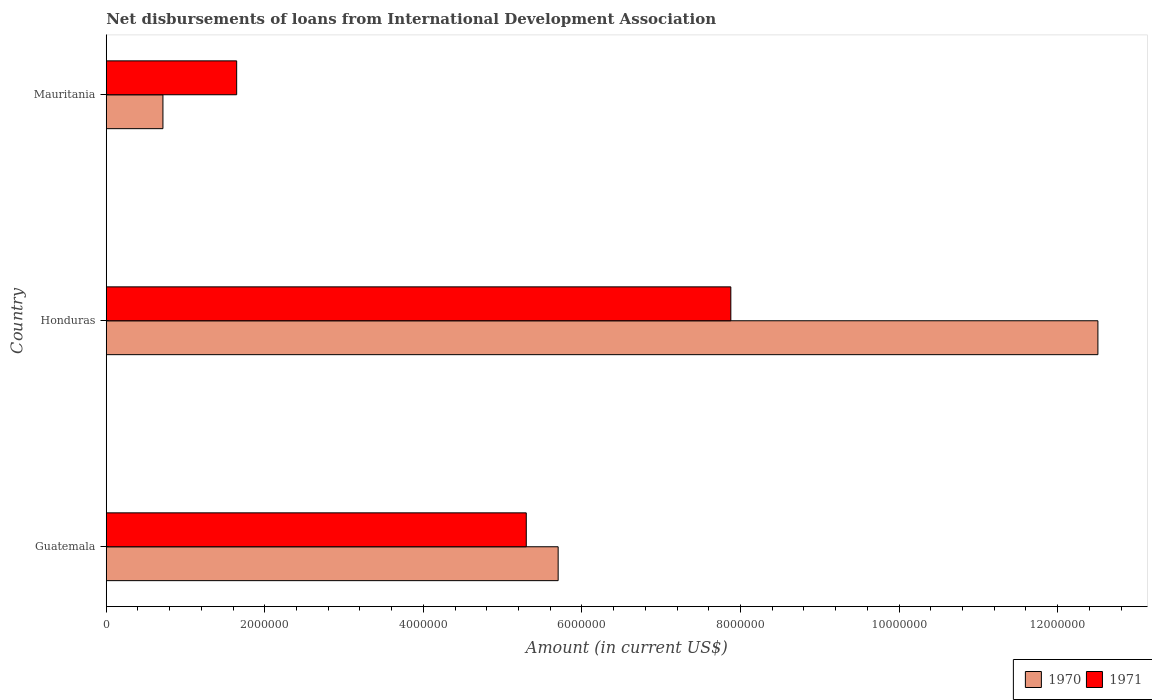How many groups of bars are there?
Your answer should be very brief. 3. Are the number of bars on each tick of the Y-axis equal?
Give a very brief answer. Yes. How many bars are there on the 3rd tick from the top?
Offer a terse response. 2. How many bars are there on the 3rd tick from the bottom?
Provide a short and direct response. 2. What is the label of the 2nd group of bars from the top?
Your answer should be very brief. Honduras. In how many cases, is the number of bars for a given country not equal to the number of legend labels?
Make the answer very short. 0. What is the amount of loans disbursed in 1971 in Guatemala?
Your answer should be very brief. 5.30e+06. Across all countries, what is the maximum amount of loans disbursed in 1971?
Provide a succinct answer. 7.88e+06. Across all countries, what is the minimum amount of loans disbursed in 1970?
Your answer should be very brief. 7.15e+05. In which country was the amount of loans disbursed in 1971 maximum?
Offer a very short reply. Honduras. In which country was the amount of loans disbursed in 1971 minimum?
Offer a very short reply. Mauritania. What is the total amount of loans disbursed in 1971 in the graph?
Your response must be concise. 1.48e+07. What is the difference between the amount of loans disbursed in 1970 in Honduras and that in Mauritania?
Provide a succinct answer. 1.18e+07. What is the difference between the amount of loans disbursed in 1971 in Honduras and the amount of loans disbursed in 1970 in Guatemala?
Offer a terse response. 2.18e+06. What is the average amount of loans disbursed in 1970 per country?
Ensure brevity in your answer.  6.31e+06. What is the difference between the amount of loans disbursed in 1971 and amount of loans disbursed in 1970 in Honduras?
Make the answer very short. -4.63e+06. What is the ratio of the amount of loans disbursed in 1970 in Guatemala to that in Honduras?
Provide a succinct answer. 0.46. Is the amount of loans disbursed in 1971 in Honduras less than that in Mauritania?
Provide a short and direct response. No. What is the difference between the highest and the second highest amount of loans disbursed in 1970?
Make the answer very short. 6.81e+06. What is the difference between the highest and the lowest amount of loans disbursed in 1970?
Your answer should be compact. 1.18e+07. In how many countries, is the amount of loans disbursed in 1971 greater than the average amount of loans disbursed in 1971 taken over all countries?
Offer a terse response. 2. Is the sum of the amount of loans disbursed in 1970 in Guatemala and Mauritania greater than the maximum amount of loans disbursed in 1971 across all countries?
Provide a succinct answer. No. What does the 2nd bar from the bottom in Honduras represents?
Your response must be concise. 1971. Are all the bars in the graph horizontal?
Provide a short and direct response. Yes. How many countries are there in the graph?
Provide a succinct answer. 3. What is the difference between two consecutive major ticks on the X-axis?
Offer a very short reply. 2.00e+06. Where does the legend appear in the graph?
Offer a terse response. Bottom right. How many legend labels are there?
Give a very brief answer. 2. How are the legend labels stacked?
Your answer should be very brief. Horizontal. What is the title of the graph?
Your response must be concise. Net disbursements of loans from International Development Association. Does "1981" appear as one of the legend labels in the graph?
Offer a terse response. No. What is the label or title of the X-axis?
Make the answer very short. Amount (in current US$). What is the label or title of the Y-axis?
Your answer should be very brief. Country. What is the Amount (in current US$) of 1970 in Guatemala?
Keep it short and to the point. 5.70e+06. What is the Amount (in current US$) in 1971 in Guatemala?
Give a very brief answer. 5.30e+06. What is the Amount (in current US$) of 1970 in Honduras?
Make the answer very short. 1.25e+07. What is the Amount (in current US$) in 1971 in Honduras?
Your answer should be very brief. 7.88e+06. What is the Amount (in current US$) in 1970 in Mauritania?
Your answer should be very brief. 7.15e+05. What is the Amount (in current US$) in 1971 in Mauritania?
Give a very brief answer. 1.64e+06. Across all countries, what is the maximum Amount (in current US$) in 1970?
Provide a succinct answer. 1.25e+07. Across all countries, what is the maximum Amount (in current US$) of 1971?
Keep it short and to the point. 7.88e+06. Across all countries, what is the minimum Amount (in current US$) of 1970?
Your answer should be compact. 7.15e+05. Across all countries, what is the minimum Amount (in current US$) of 1971?
Your answer should be very brief. 1.64e+06. What is the total Amount (in current US$) in 1970 in the graph?
Your answer should be compact. 1.89e+07. What is the total Amount (in current US$) in 1971 in the graph?
Keep it short and to the point. 1.48e+07. What is the difference between the Amount (in current US$) of 1970 in Guatemala and that in Honduras?
Offer a very short reply. -6.81e+06. What is the difference between the Amount (in current US$) in 1971 in Guatemala and that in Honduras?
Keep it short and to the point. -2.58e+06. What is the difference between the Amount (in current US$) of 1970 in Guatemala and that in Mauritania?
Give a very brief answer. 4.98e+06. What is the difference between the Amount (in current US$) of 1971 in Guatemala and that in Mauritania?
Give a very brief answer. 3.65e+06. What is the difference between the Amount (in current US$) in 1970 in Honduras and that in Mauritania?
Your answer should be compact. 1.18e+07. What is the difference between the Amount (in current US$) of 1971 in Honduras and that in Mauritania?
Offer a very short reply. 6.23e+06. What is the difference between the Amount (in current US$) in 1970 in Guatemala and the Amount (in current US$) in 1971 in Honduras?
Your answer should be compact. -2.18e+06. What is the difference between the Amount (in current US$) in 1970 in Guatemala and the Amount (in current US$) in 1971 in Mauritania?
Your response must be concise. 4.06e+06. What is the difference between the Amount (in current US$) in 1970 in Honduras and the Amount (in current US$) in 1971 in Mauritania?
Your answer should be very brief. 1.09e+07. What is the average Amount (in current US$) in 1970 per country?
Provide a short and direct response. 6.31e+06. What is the average Amount (in current US$) in 1971 per country?
Your answer should be very brief. 4.94e+06. What is the difference between the Amount (in current US$) of 1970 and Amount (in current US$) of 1971 in Guatemala?
Provide a short and direct response. 4.02e+05. What is the difference between the Amount (in current US$) in 1970 and Amount (in current US$) in 1971 in Honduras?
Provide a succinct answer. 4.63e+06. What is the difference between the Amount (in current US$) of 1970 and Amount (in current US$) of 1971 in Mauritania?
Give a very brief answer. -9.30e+05. What is the ratio of the Amount (in current US$) in 1970 in Guatemala to that in Honduras?
Offer a terse response. 0.46. What is the ratio of the Amount (in current US$) of 1971 in Guatemala to that in Honduras?
Your answer should be compact. 0.67. What is the ratio of the Amount (in current US$) of 1970 in Guatemala to that in Mauritania?
Your response must be concise. 7.97. What is the ratio of the Amount (in current US$) in 1971 in Guatemala to that in Mauritania?
Your response must be concise. 3.22. What is the ratio of the Amount (in current US$) of 1970 in Honduras to that in Mauritania?
Make the answer very short. 17.49. What is the ratio of the Amount (in current US$) in 1971 in Honduras to that in Mauritania?
Keep it short and to the point. 4.79. What is the difference between the highest and the second highest Amount (in current US$) in 1970?
Make the answer very short. 6.81e+06. What is the difference between the highest and the second highest Amount (in current US$) in 1971?
Your answer should be compact. 2.58e+06. What is the difference between the highest and the lowest Amount (in current US$) in 1970?
Keep it short and to the point. 1.18e+07. What is the difference between the highest and the lowest Amount (in current US$) of 1971?
Offer a very short reply. 6.23e+06. 